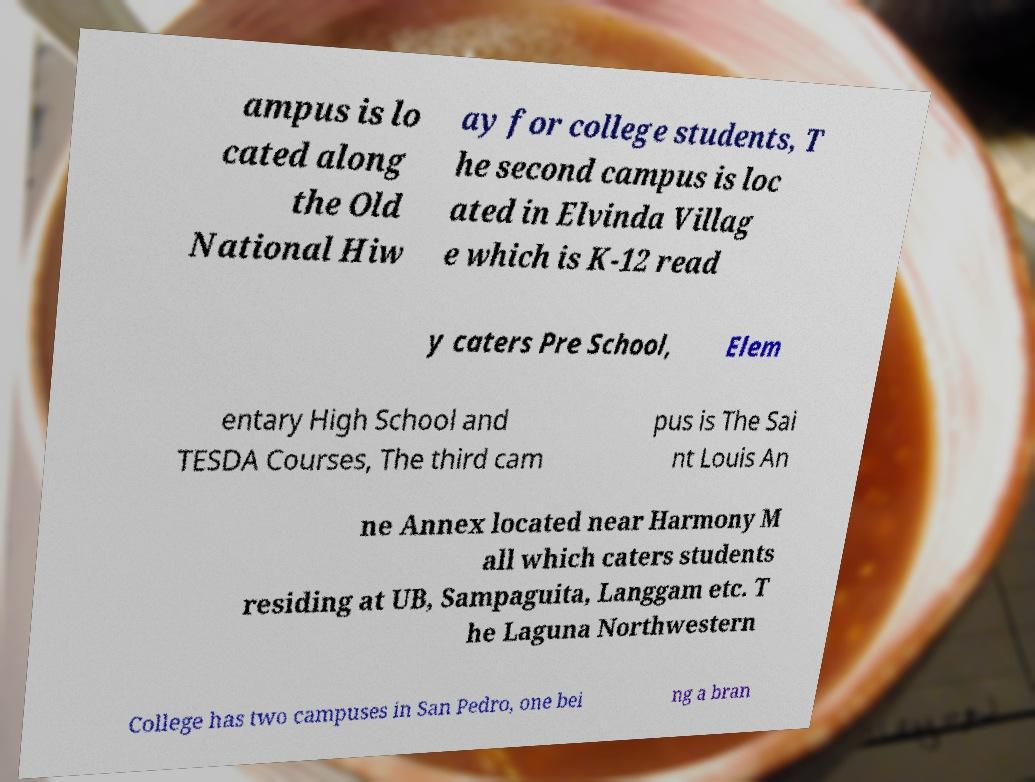For documentation purposes, I need the text within this image transcribed. Could you provide that? ampus is lo cated along the Old National Hiw ay for college students, T he second campus is loc ated in Elvinda Villag e which is K-12 read y caters Pre School, Elem entary High School and TESDA Courses, The third cam pus is The Sai nt Louis An ne Annex located near Harmony M all which caters students residing at UB, Sampaguita, Langgam etc. T he Laguna Northwestern College has two campuses in San Pedro, one bei ng a bran 